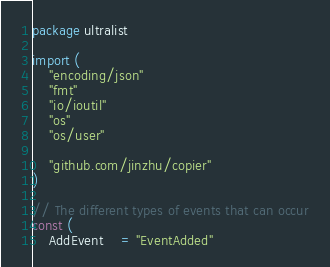<code> <loc_0><loc_0><loc_500><loc_500><_Go_>package ultralist

import (
	"encoding/json"
	"fmt"
	"io/ioutil"
	"os"
	"os/user"

	"github.com/jinzhu/copier"
)

// The different types of events that can occur
const (
	AddEvent    = "EventAdded"</code> 